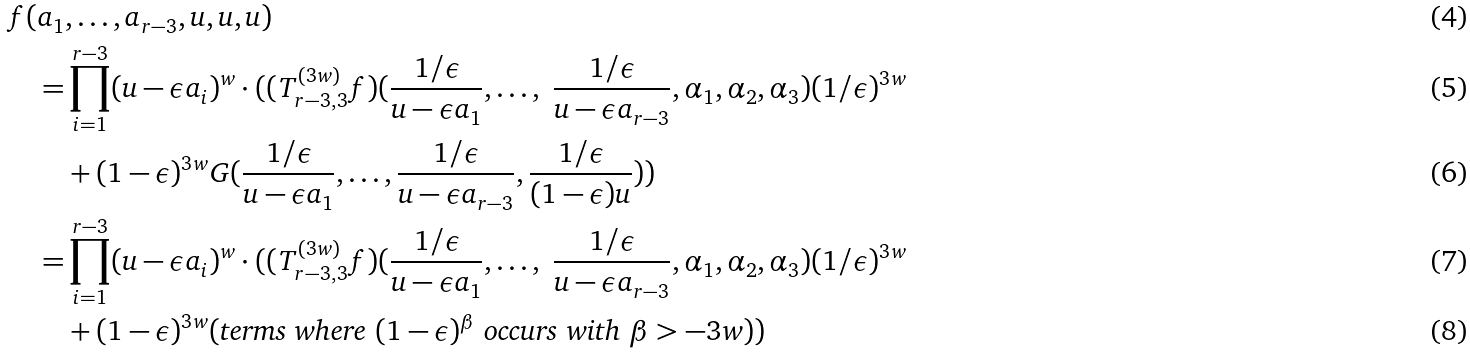<formula> <loc_0><loc_0><loc_500><loc_500>f ( a _ { 1 } & , \dots , a _ { r - 3 } , u , u , u ) \\ = & \prod _ { i = 1 } ^ { r - 3 } ( u - \epsilon a _ { i } ) ^ { w } \cdot ( ( T _ { r - 3 , 3 } ^ { ( 3 w ) } f ) ( \frac { 1 / \epsilon } { u - \epsilon a _ { 1 } } , \dots , \ \frac { 1 / \epsilon } { u - \epsilon a _ { r - 3 } } , \alpha _ { 1 } , \alpha _ { 2 } , \alpha _ { 3 } ) ( 1 / \epsilon ) ^ { 3 w } \\ & + ( 1 - \epsilon ) ^ { 3 w } G ( \frac { 1 / \epsilon } { u - \epsilon a _ { 1 } } , \dots , \frac { 1 / \epsilon } { u - \epsilon a _ { r - 3 } } , \frac { 1 / \epsilon } { ( 1 - \epsilon ) u } ) ) \\ = & \prod _ { i = 1 } ^ { r - 3 } ( u - \epsilon a _ { i } ) ^ { w } \cdot ( ( T _ { r - 3 , 3 } ^ { ( 3 w ) } f ) ( \frac { 1 / \epsilon } { u - \epsilon a _ { 1 } } , \dots , \ \frac { 1 / \epsilon } { u - \epsilon a _ { r - 3 } } , \alpha _ { 1 } , \alpha _ { 2 } , \alpha _ { 3 } ) ( 1 / \epsilon ) ^ { 3 w } \\ & + ( 1 - \epsilon ) ^ { 3 w } ( \text {terms where $(1-\epsilon)^{\beta}$ occurs with $\beta>-3w$} ) )</formula> 